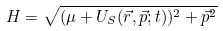Convert formula to latex. <formula><loc_0><loc_0><loc_500><loc_500>H = \sqrt { ( \mu + U _ { S } ( \vec { r } , \vec { p } ; t ) ) ^ { 2 } + { \vec { p } } ^ { 2 } }</formula> 